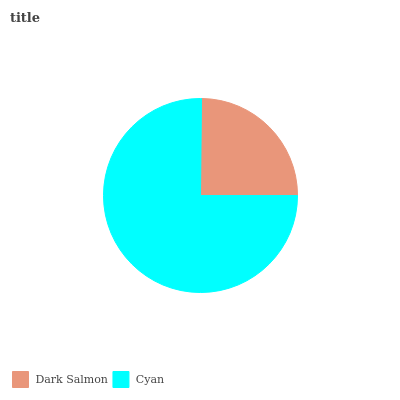Is Dark Salmon the minimum?
Answer yes or no. Yes. Is Cyan the maximum?
Answer yes or no. Yes. Is Cyan the minimum?
Answer yes or no. No. Is Cyan greater than Dark Salmon?
Answer yes or no. Yes. Is Dark Salmon less than Cyan?
Answer yes or no. Yes. Is Dark Salmon greater than Cyan?
Answer yes or no. No. Is Cyan less than Dark Salmon?
Answer yes or no. No. Is Cyan the high median?
Answer yes or no. Yes. Is Dark Salmon the low median?
Answer yes or no. Yes. Is Dark Salmon the high median?
Answer yes or no. No. Is Cyan the low median?
Answer yes or no. No. 